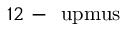Convert formula to latex. <formula><loc_0><loc_0><loc_500><loc_500>1 2 - \ u p m u s</formula> 